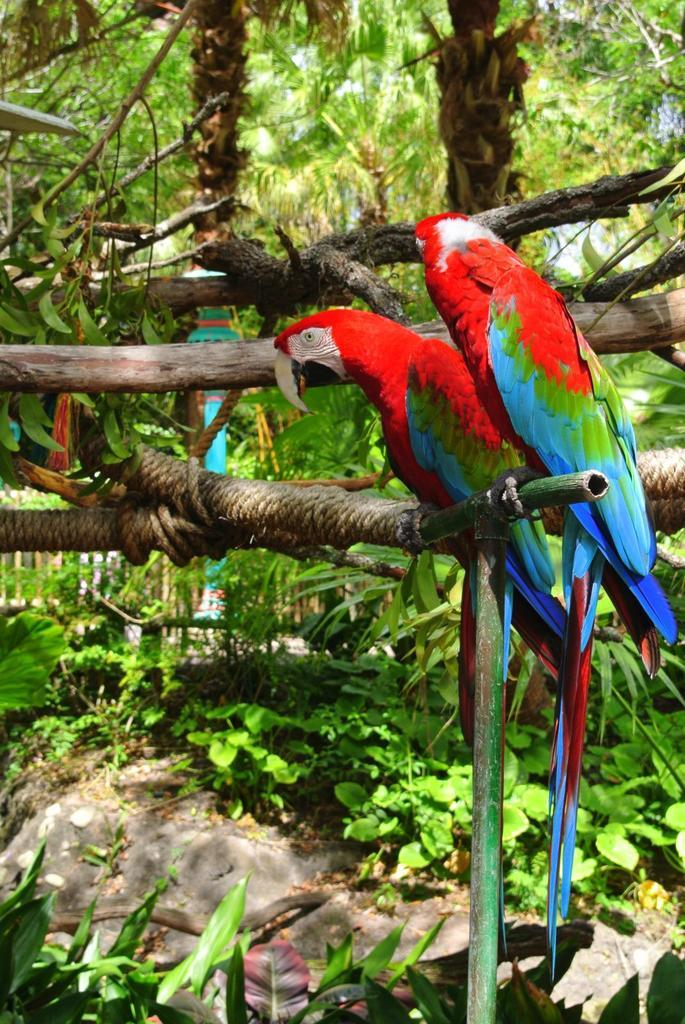How many parrots are in the image? There are two parrots in the image. What are the parrots doing in the image? The parrots are standing on a tree branch. What can be seen in the background of the image? There is a wooden fence, rocks, and plants in the background of the image. What route do the parrots take to reach the spot on the tree branch? The image does not provide information about how the parrots reached the tree branch, so we cannot determine their route. 